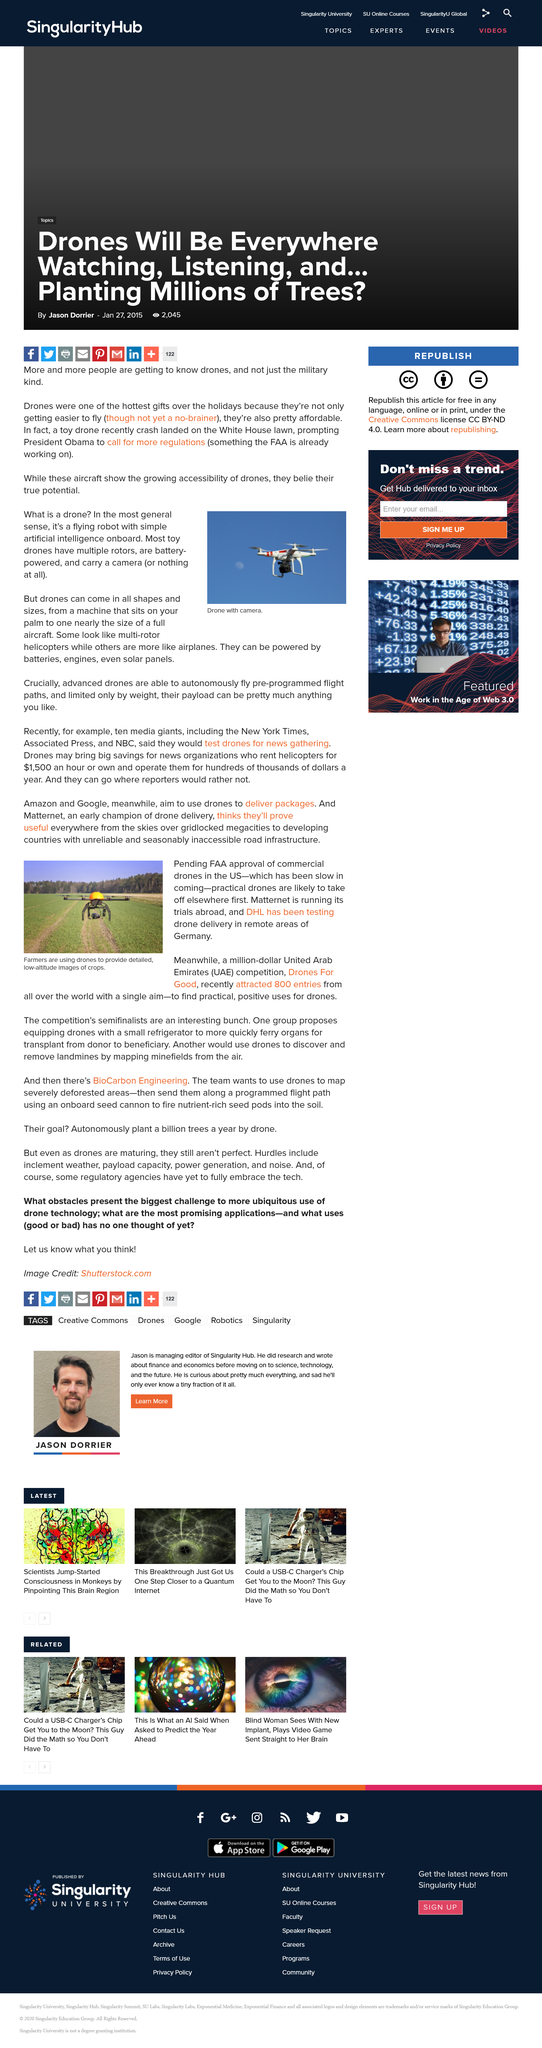Draw attention to some important aspects in this diagram. Drones For Good is a competition aimed at incentivizing the use of drones in the UAE for the betterment of society. The competition offers a prize of one million dollars to the individual or team that can demonstrate the most innovative and impactful use of drones for positive social or environmental outcomes. Drones can be powered by a variety of methods, including batteries, engines, and even solar panels. The competition Drones for Good received 800 entries in total. A drone is a flying robot equipped with basic artificial intelligence that enables it to operate autonomously in the air. Drones are commonly used by farmers to obtain detailed low-altitude images of their crops. This enables farmers to monitor the health and growth of their crops, identify areas that require attention, and make informed decisions about crop management. 